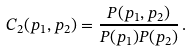Convert formula to latex. <formula><loc_0><loc_0><loc_500><loc_500>C _ { 2 } ( { p } _ { 1 } , { p } _ { 2 } ) = \frac { P ( { p } _ { 1 } , { p } _ { 2 } ) } { P ( { p } _ { 1 } ) P ( { p } _ { 2 } ) } \, .</formula> 